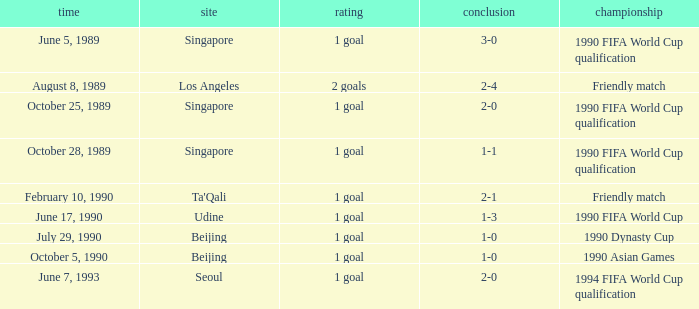What is the score of the match on July 29, 1990? 1 goal. 